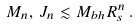Convert formula to latex. <formula><loc_0><loc_0><loc_500><loc_500>M _ { n } , \, J _ { n } \lesssim M _ { b h } R _ { s } ^ { n } \, .</formula> 